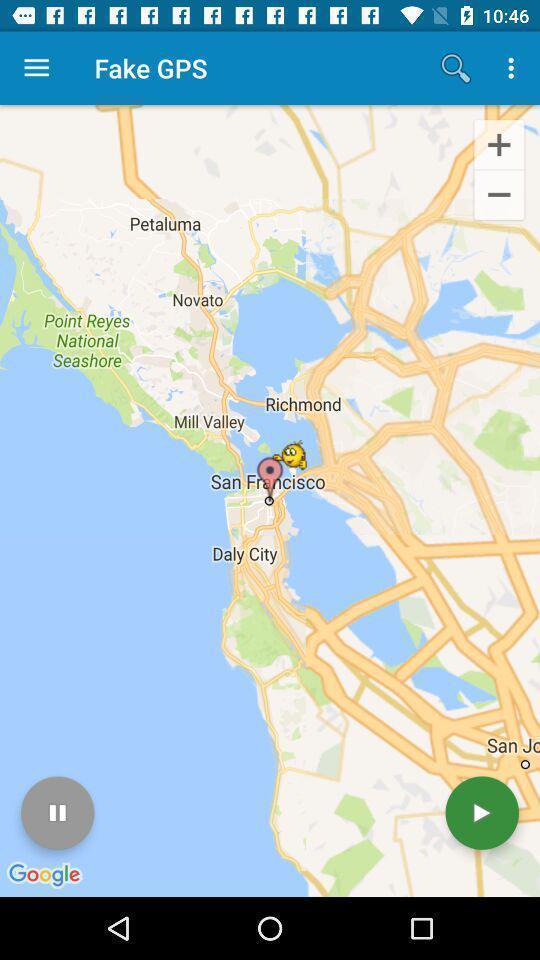Explain the elements present in this screenshot. Search page of fake gps. 